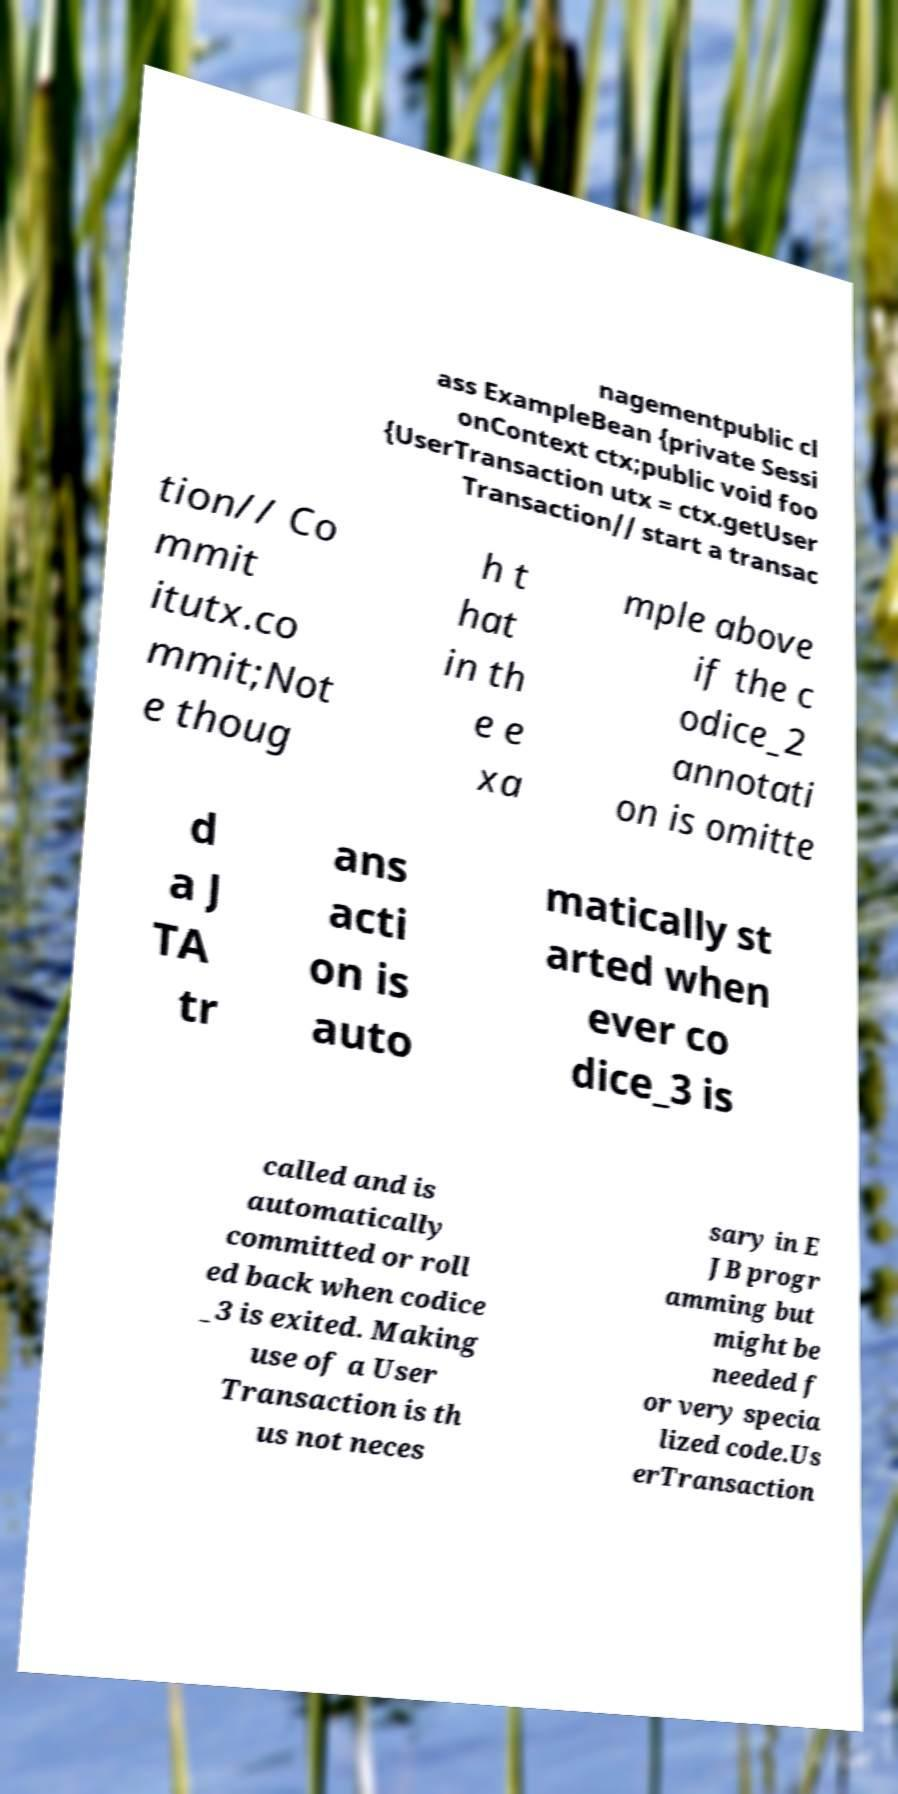Could you extract and type out the text from this image? nagementpublic cl ass ExampleBean {private Sessi onContext ctx;public void foo {UserTransaction utx = ctx.getUser Transaction// start a transac tion// Co mmit itutx.co mmit;Not e thoug h t hat in th e e xa mple above if the c odice_2 annotati on is omitte d a J TA tr ans acti on is auto matically st arted when ever co dice_3 is called and is automatically committed or roll ed back when codice _3 is exited. Making use of a User Transaction is th us not neces sary in E JB progr amming but might be needed f or very specia lized code.Us erTransaction 